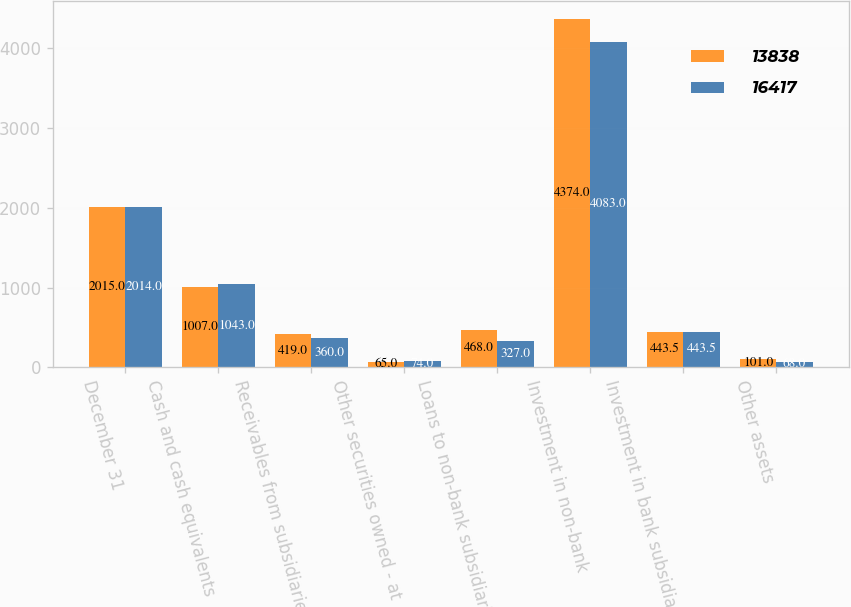Convert chart. <chart><loc_0><loc_0><loc_500><loc_500><stacked_bar_chart><ecel><fcel>December 31<fcel>Cash and cash equivalents<fcel>Receivables from subsidiaries<fcel>Other securities owned - at<fcel>Loans to non-bank subsidiaries<fcel>Investment in non-bank<fcel>Investment in bank subsidiary<fcel>Other assets<nl><fcel>13838<fcel>2015<fcel>1007<fcel>419<fcel>65<fcel>468<fcel>4374<fcel>443.5<fcel>101<nl><fcel>16417<fcel>2014<fcel>1043<fcel>360<fcel>74<fcel>327<fcel>4083<fcel>443.5<fcel>68<nl></chart> 